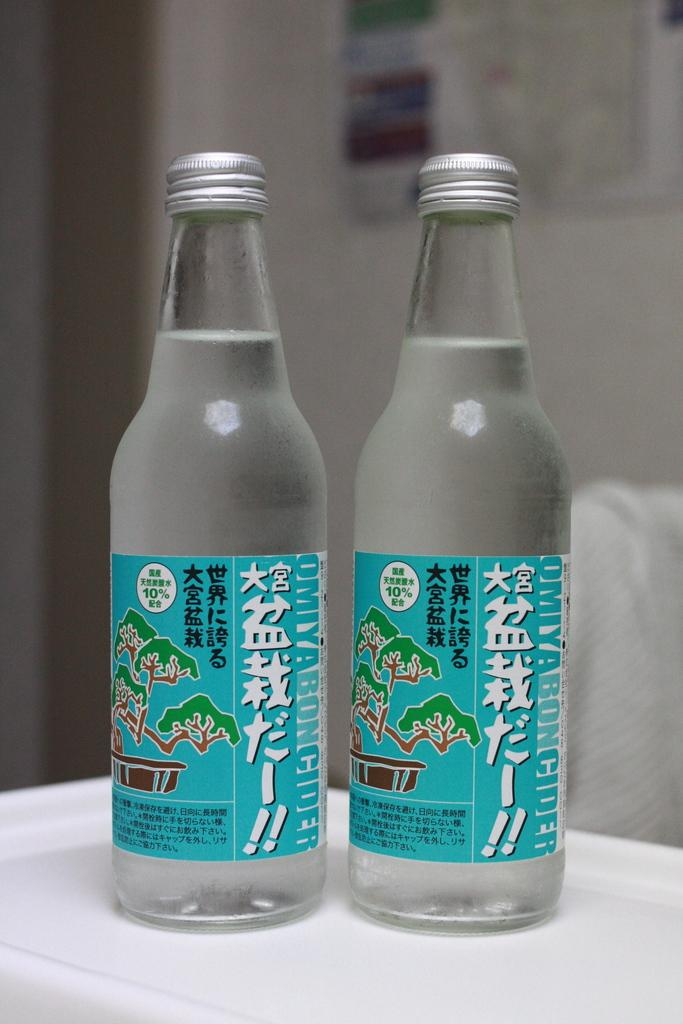How many bottles are visible in the image? There are two bottles in the image. Where are the bottles located? The bottles are on a table. Can you see the mom and men at the seashore in the image? There is no mention of a mom, men, or seashore in the image; it only features two bottles on a table. 